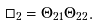<formula> <loc_0><loc_0><loc_500><loc_500>\Box _ { 2 } = \Theta _ { 2 1 } \Theta _ { 2 2 } .</formula> 